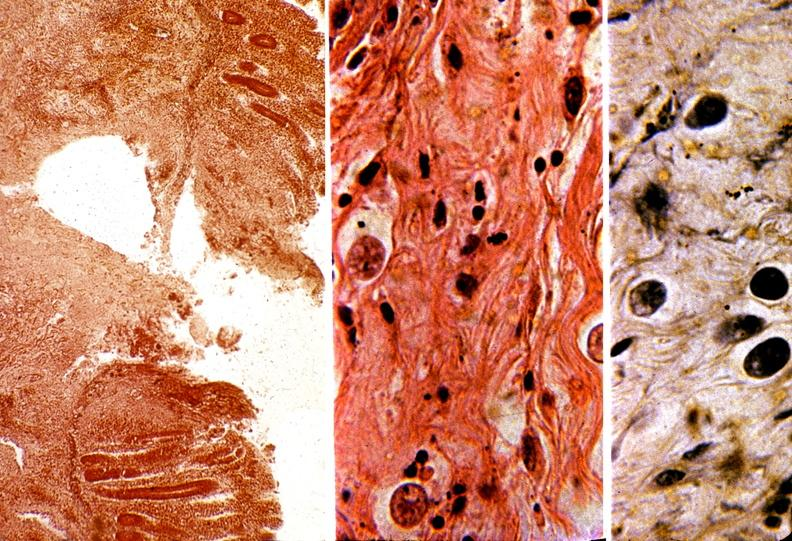does this image show colon, amebic colitis?
Answer the question using a single word or phrase. Yes 